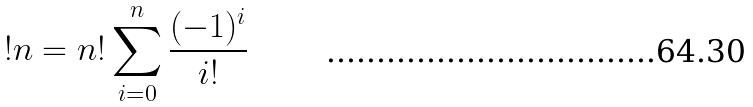Convert formula to latex. <formula><loc_0><loc_0><loc_500><loc_500>! n = n ! \sum _ { i = 0 } ^ { n } \frac { ( - 1 ) ^ { i } } { i ! }</formula> 